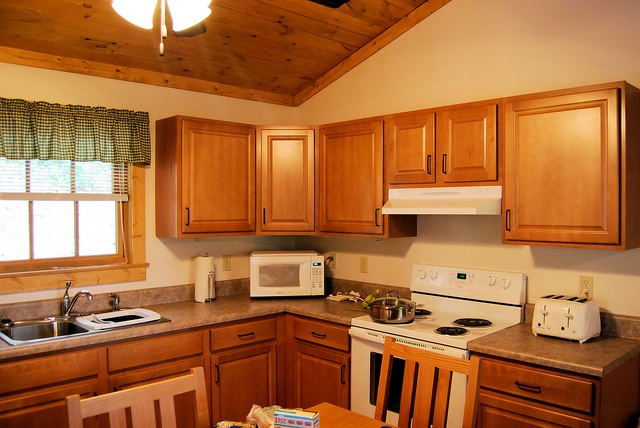Describe the objects in this image and their specific colors. I can see oven in maroon, tan, and black tones, chair in maroon, red, black, and tan tones, chair in maroon, salmon, red, and tan tones, microwave in maroon, tan, brown, and gray tones, and toaster in maroon and tan tones in this image. 